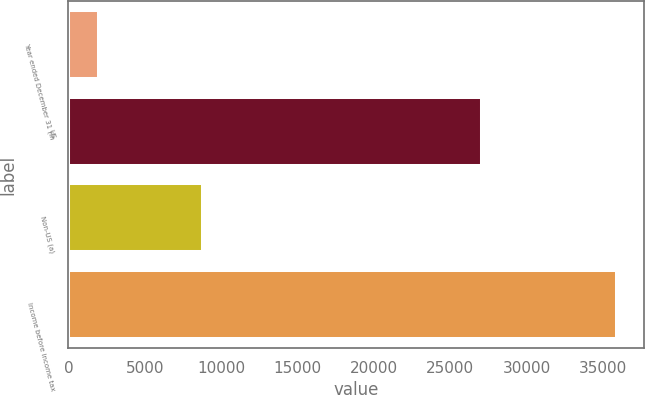Convert chart to OTSL. <chart><loc_0><loc_0><loc_500><loc_500><bar_chart><fcel>Year ended December 31 (in<fcel>US<fcel>Non-US (a)<fcel>Income before income tax<nl><fcel>2017<fcel>27103<fcel>8797<fcel>35900<nl></chart> 